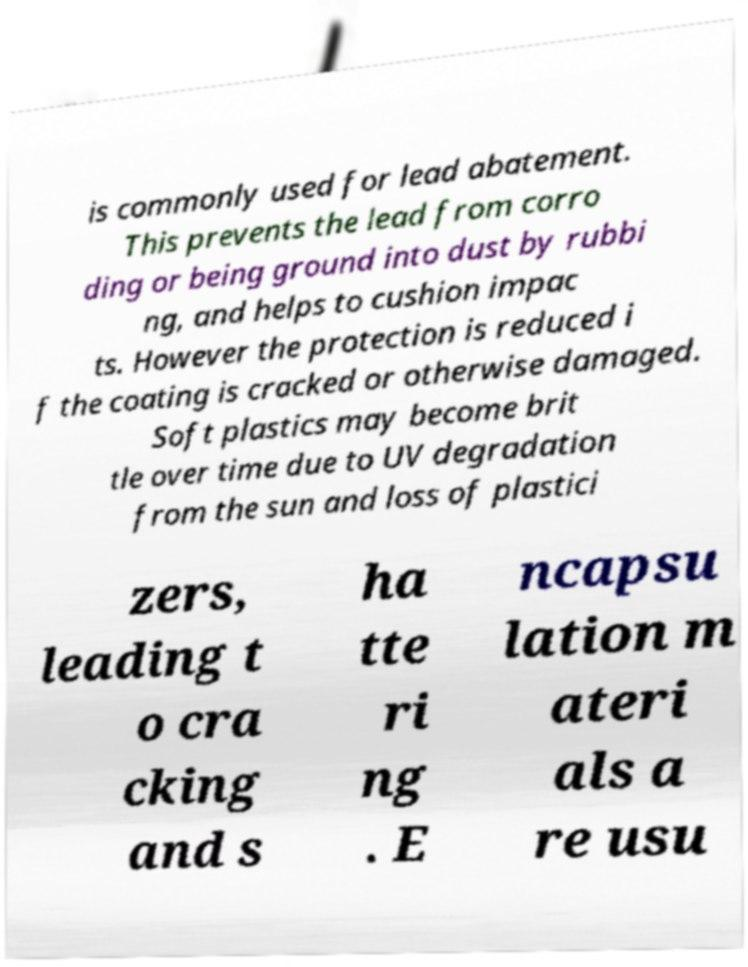Can you accurately transcribe the text from the provided image for me? is commonly used for lead abatement. This prevents the lead from corro ding or being ground into dust by rubbi ng, and helps to cushion impac ts. However the protection is reduced i f the coating is cracked or otherwise damaged. Soft plastics may become brit tle over time due to UV degradation from the sun and loss of plastici zers, leading t o cra cking and s ha tte ri ng . E ncapsu lation m ateri als a re usu 